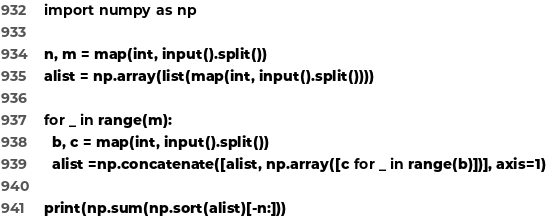<code> <loc_0><loc_0><loc_500><loc_500><_Python_>import numpy as np

n, m = map(int, input().split())
alist = np.array(list(map(int, input().split())))

for _ in range(m):
  b, c = map(int, input().split())
  alist =np.concatenate([alist, np.array([c for _ in range(b)])], axis=1)

print(np.sum(np.sort(alist)[-n:]))</code> 